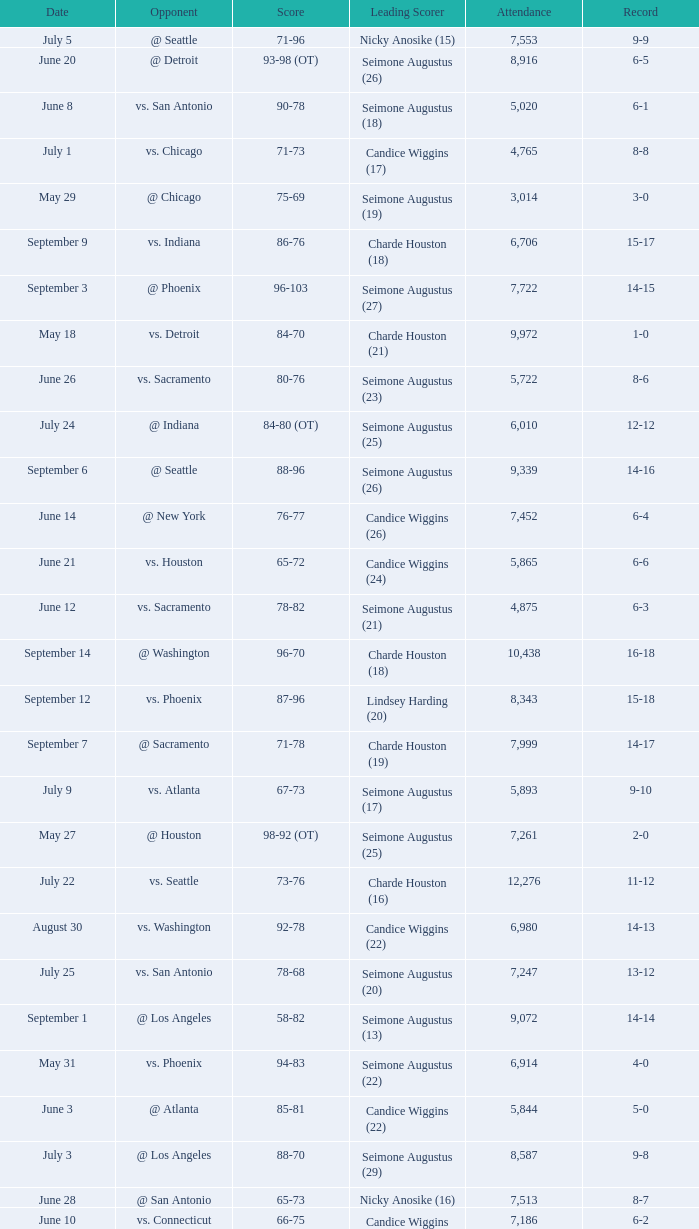Which Score has an Opponent of @ houston, and a Record of 2-0? 98-92 (OT). 